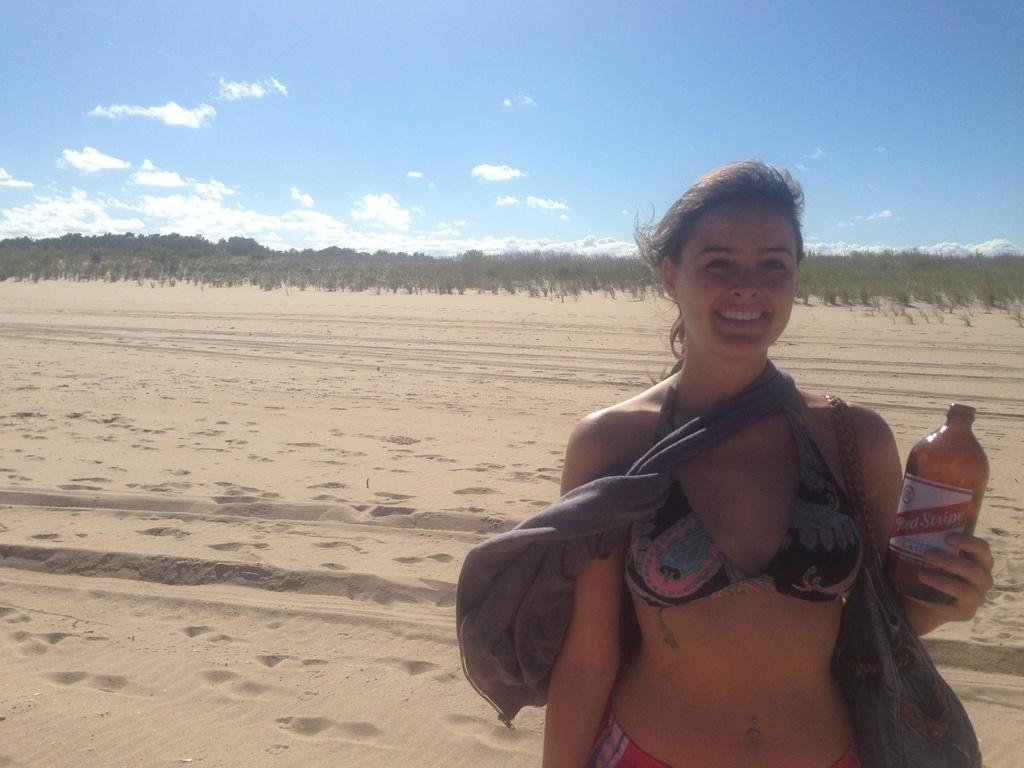What is the setting of the image? The image is of the outskirts of a city. Who is present in the image? There is a woman in the image. What is the woman doing in the image? The woman is standing and smiling. What is the woman holding in the image? The woman is holding a bottle. What can be seen in the sky in the image? The sky is visible in the image. What type of vegetation is visible in the image? There are trees visible in the image. What type of blade is the woman using to cut the ticket in the image? There is no blade or ticket present in the image. 